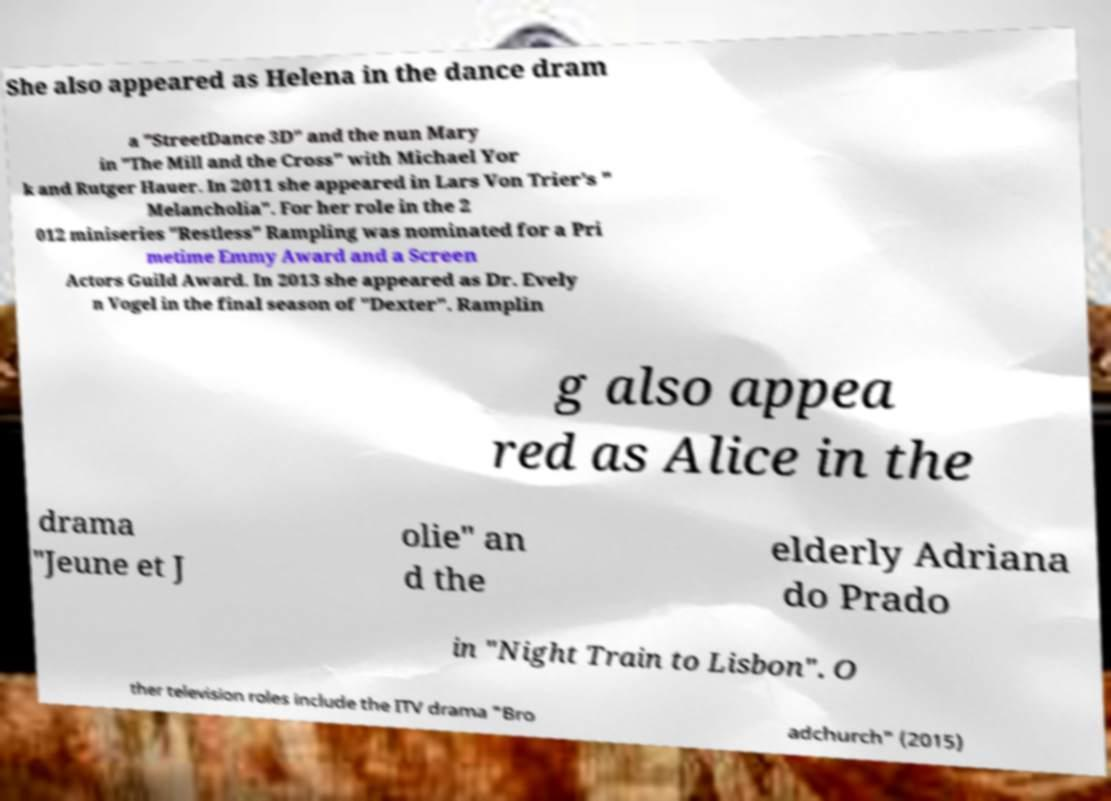Could you extract and type out the text from this image? She also appeared as Helena in the dance dram a "StreetDance 3D" and the nun Mary in "The Mill and the Cross" with Michael Yor k and Rutger Hauer. In 2011 she appeared in Lars Von Trier's " Melancholia". For her role in the 2 012 miniseries "Restless" Rampling was nominated for a Pri metime Emmy Award and a Screen Actors Guild Award. In 2013 she appeared as Dr. Evely n Vogel in the final season of "Dexter". Ramplin g also appea red as Alice in the drama "Jeune et J olie" an d the elderly Adriana do Prado in "Night Train to Lisbon". O ther television roles include the ITV drama "Bro adchurch" (2015) 